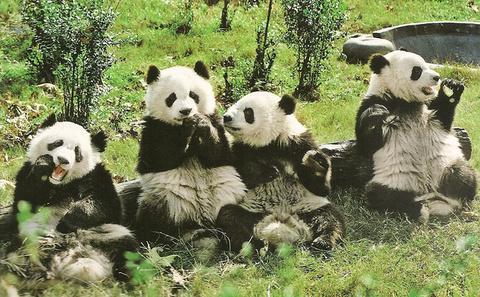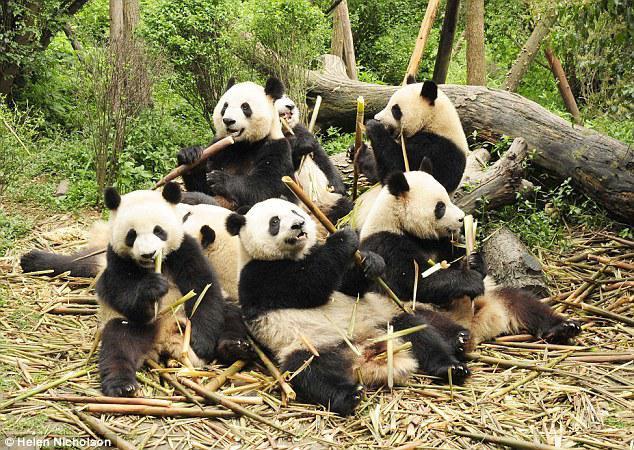The first image is the image on the left, the second image is the image on the right. Given the left and right images, does the statement "No image contains more than three pandas, one image contains a single panda, and a structure made of horizontal wooden poles is pictured in an image." hold true? Answer yes or no. No. The first image is the image on the left, the second image is the image on the right. Considering the images on both sides, is "There are no more than four panda bears." valid? Answer yes or no. No. 